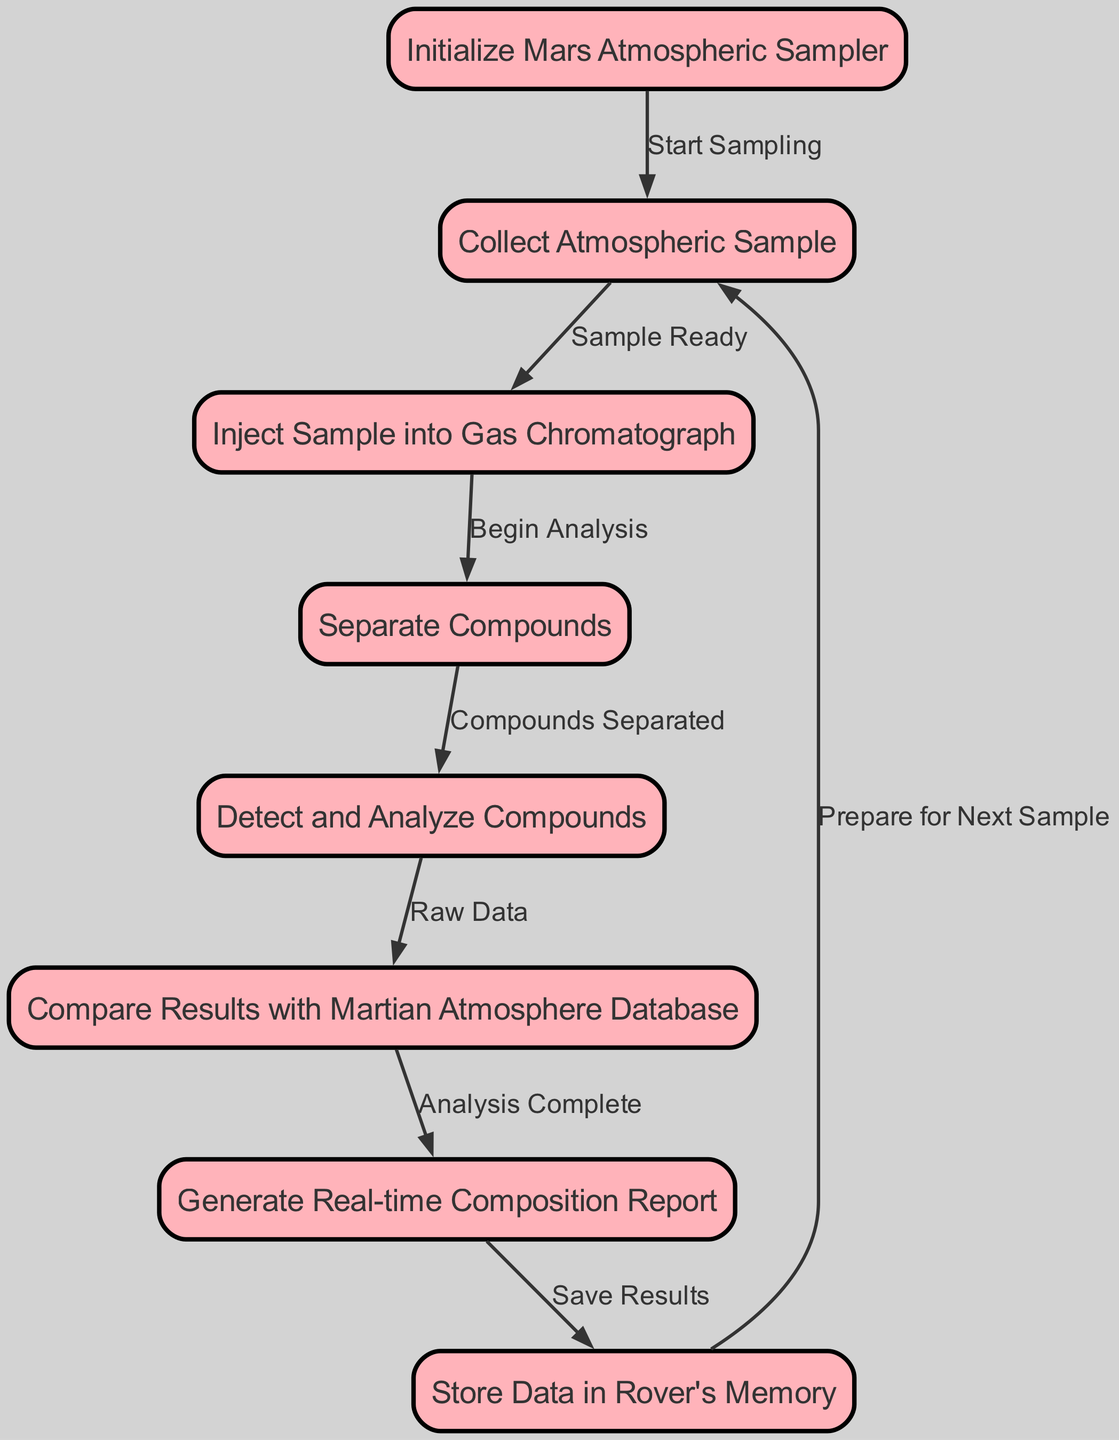What is the first step in the flowchart? The first step is represented by node "1", which indicates "Initialize Mars Atmospheric Sampler".
Answer: Initialize Mars Atmospheric Sampler How many nodes are in the flowchart? By counting the "nodes" entries in the provided data, there are a total of 8 nodes.
Answer: 8 Which node follows the "Collect Atmospheric Sample" step? The edge leading from node "2" ("Collect Atmospheric Sample") points to node "3" ("Inject Sample into Gas Chromatograph").
Answer: Inject Sample into Gas Chromatograph What is the output of the "Detect and Analyze Compounds" step? The output from node "5" leads directly to node "6", indicating that "Raw Data" is generated and compared with the Martian Atmosphere Database.
Answer: Raw Data Which step involves generating a report? Node "7" indicates the step "Generate Real-time Composition Report", which is where the report is created.
Answer: Generate Real-time Composition Report How does the flowchart handle preparation for the next sample? The final edge leading from node "8" connects back to node "2", indicating that it prepares for the next sample.
Answer: Prepare for Next Sample What is the relationship between "Separate Compounds" and "Detect and Analyze Compounds"? The edge from node "4" ("Separate Compounds") to node "5" ("Detect and Analyze Compounds") indicates a direct sequence, implying that separation must occur before detection and analysis.
Answer: Compounds Separated What is the last stored data related to? The last operation in the flowchart is to "Store Data in Rover's Memory", indicating the final action.
Answer: Store Data in Rover's Memory 